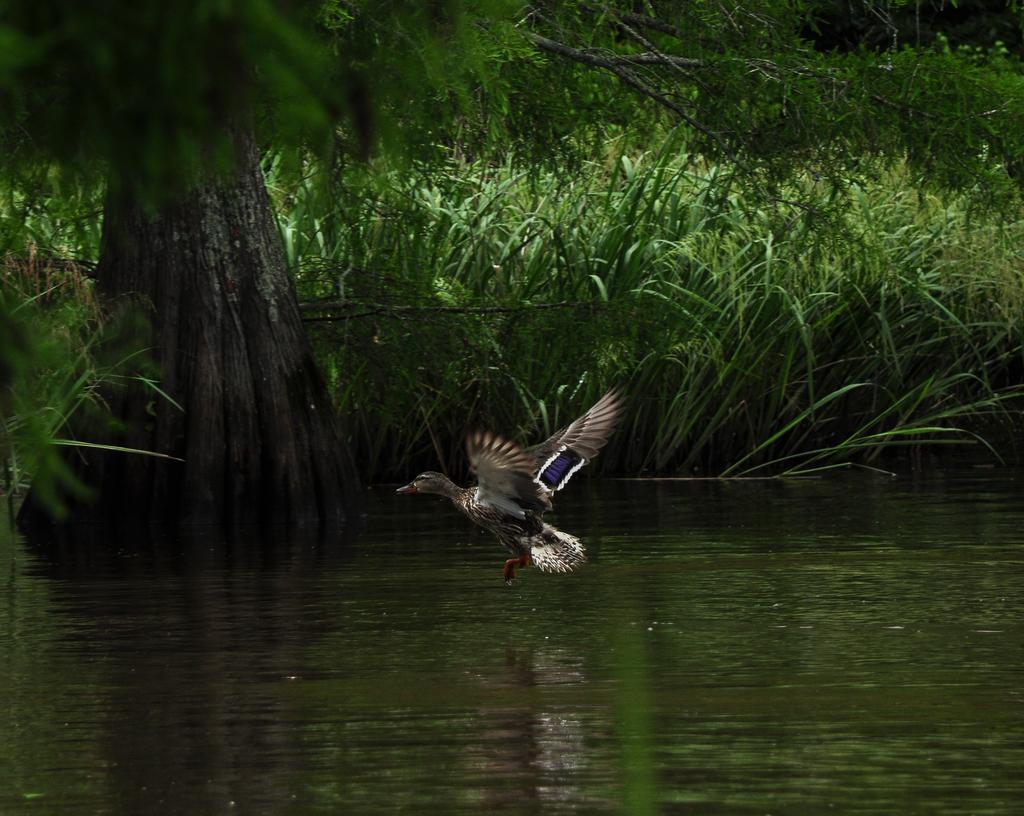Describe this image in one or two sentences. In this image I can see at the bottom there is water, in the middle a bird is flying, on the left side there is a tree. In the background there are plants. 